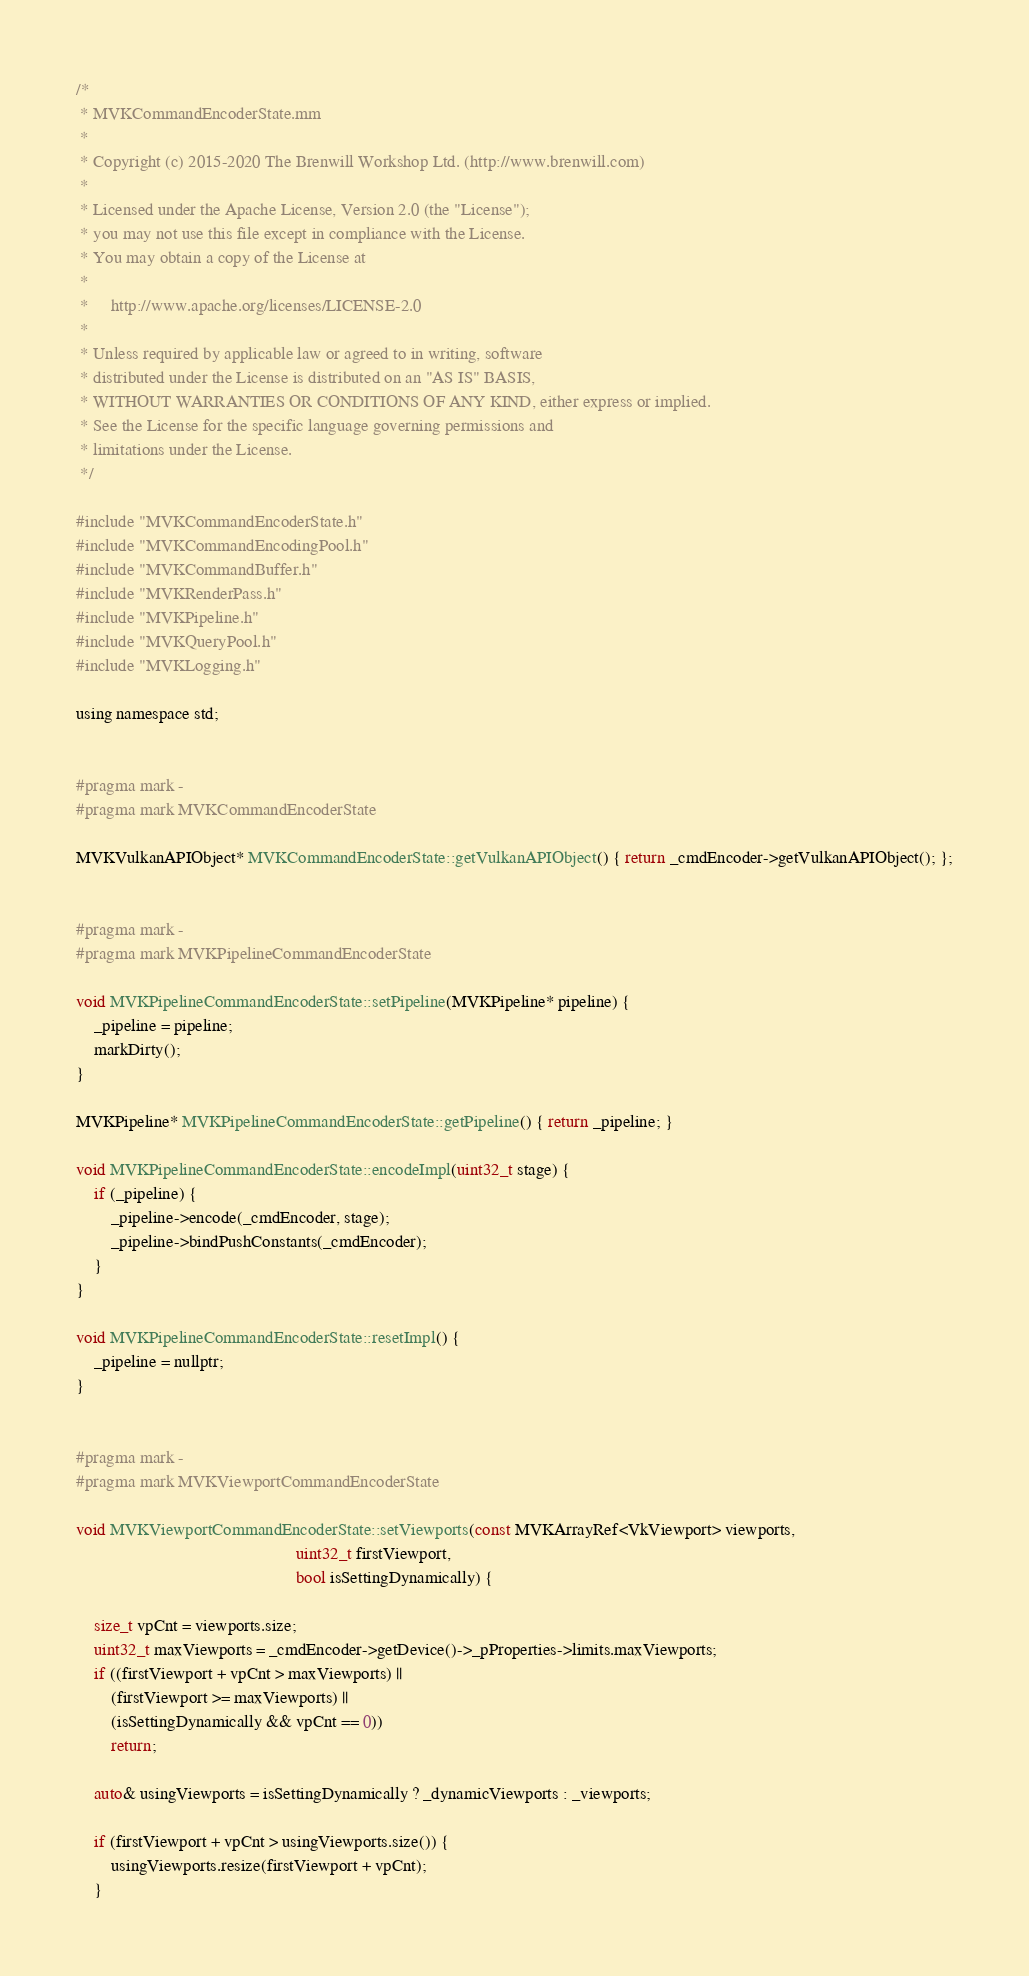Convert code to text. <code><loc_0><loc_0><loc_500><loc_500><_ObjectiveC_>/*
 * MVKCommandEncoderState.mm
 *
 * Copyright (c) 2015-2020 The Brenwill Workshop Ltd. (http://www.brenwill.com)
 *
 * Licensed under the Apache License, Version 2.0 (the "License");
 * you may not use this file except in compliance with the License.
 * You may obtain a copy of the License at
 * 
 *     http://www.apache.org/licenses/LICENSE-2.0
 * 
 * Unless required by applicable law or agreed to in writing, software
 * distributed under the License is distributed on an "AS IS" BASIS,
 * WITHOUT WARRANTIES OR CONDITIONS OF ANY KIND, either express or implied.
 * See the License for the specific language governing permissions and
 * limitations under the License.
 */

#include "MVKCommandEncoderState.h"
#include "MVKCommandEncodingPool.h"
#include "MVKCommandBuffer.h"
#include "MVKRenderPass.h"
#include "MVKPipeline.h"
#include "MVKQueryPool.h"
#include "MVKLogging.h"

using namespace std;


#pragma mark -
#pragma mark MVKCommandEncoderState

MVKVulkanAPIObject* MVKCommandEncoderState::getVulkanAPIObject() { return _cmdEncoder->getVulkanAPIObject(); };


#pragma mark -
#pragma mark MVKPipelineCommandEncoderState

void MVKPipelineCommandEncoderState::setPipeline(MVKPipeline* pipeline) {
    _pipeline = pipeline;
    markDirty();
}

MVKPipeline* MVKPipelineCommandEncoderState::getPipeline() { return _pipeline; }

void MVKPipelineCommandEncoderState::encodeImpl(uint32_t stage) {
    if (_pipeline) {
		_pipeline->encode(_cmdEncoder, stage);
		_pipeline->bindPushConstants(_cmdEncoder);
	}
}

void MVKPipelineCommandEncoderState::resetImpl() {
    _pipeline = nullptr;
}


#pragma mark -
#pragma mark MVKViewportCommandEncoderState

void MVKViewportCommandEncoderState::setViewports(const MVKArrayRef<VkViewport> viewports,
												  uint32_t firstViewport,
												  bool isSettingDynamically) {

	size_t vpCnt = viewports.size;
	uint32_t maxViewports = _cmdEncoder->getDevice()->_pProperties->limits.maxViewports;
	if ((firstViewport + vpCnt > maxViewports) ||
		(firstViewport >= maxViewports) ||
		(isSettingDynamically && vpCnt == 0))
		return;

	auto& usingViewports = isSettingDynamically ? _dynamicViewports : _viewports;

	if (firstViewport + vpCnt > usingViewports.size()) {
		usingViewports.resize(firstViewport + vpCnt);
	}
</code> 